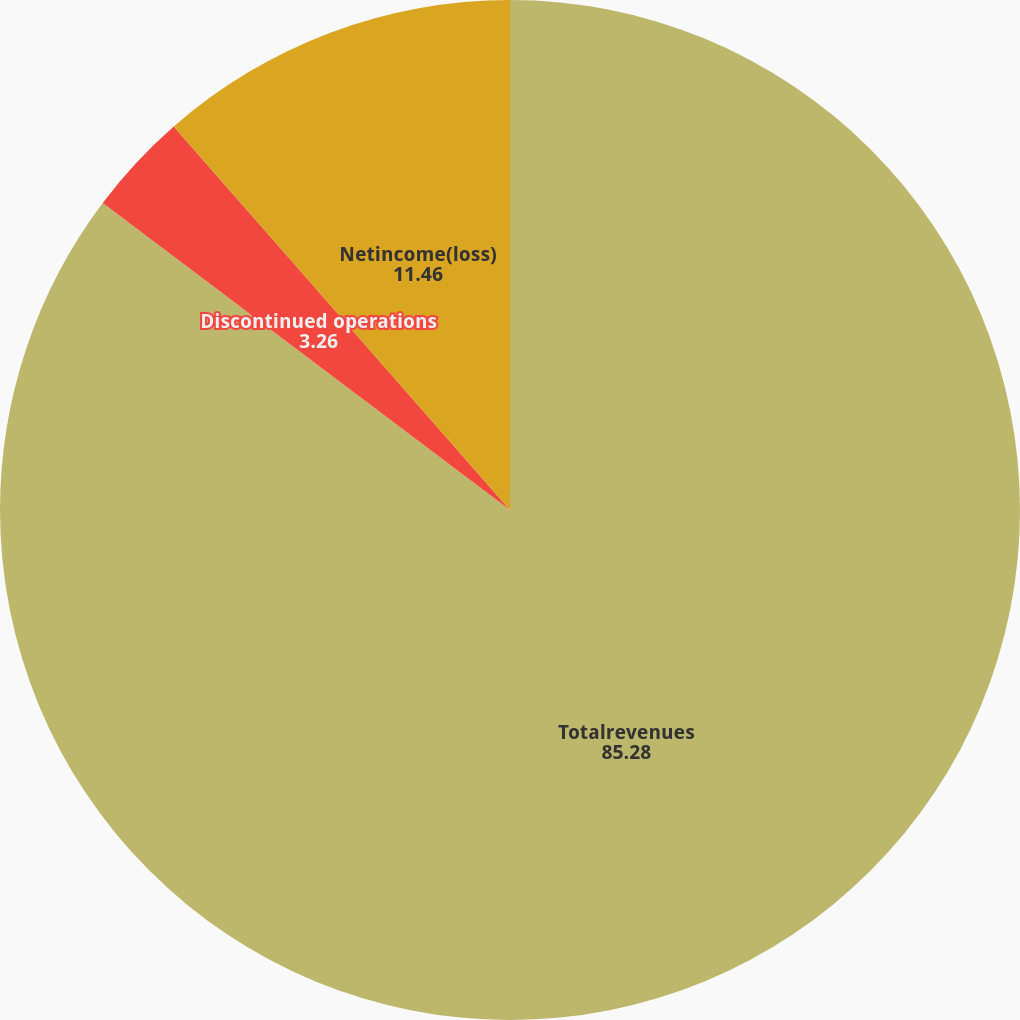<chart> <loc_0><loc_0><loc_500><loc_500><pie_chart><fcel>Totalrevenues<fcel>Discontinued operations<fcel>Netincome(loss)<nl><fcel>85.28%<fcel>3.26%<fcel>11.46%<nl></chart> 